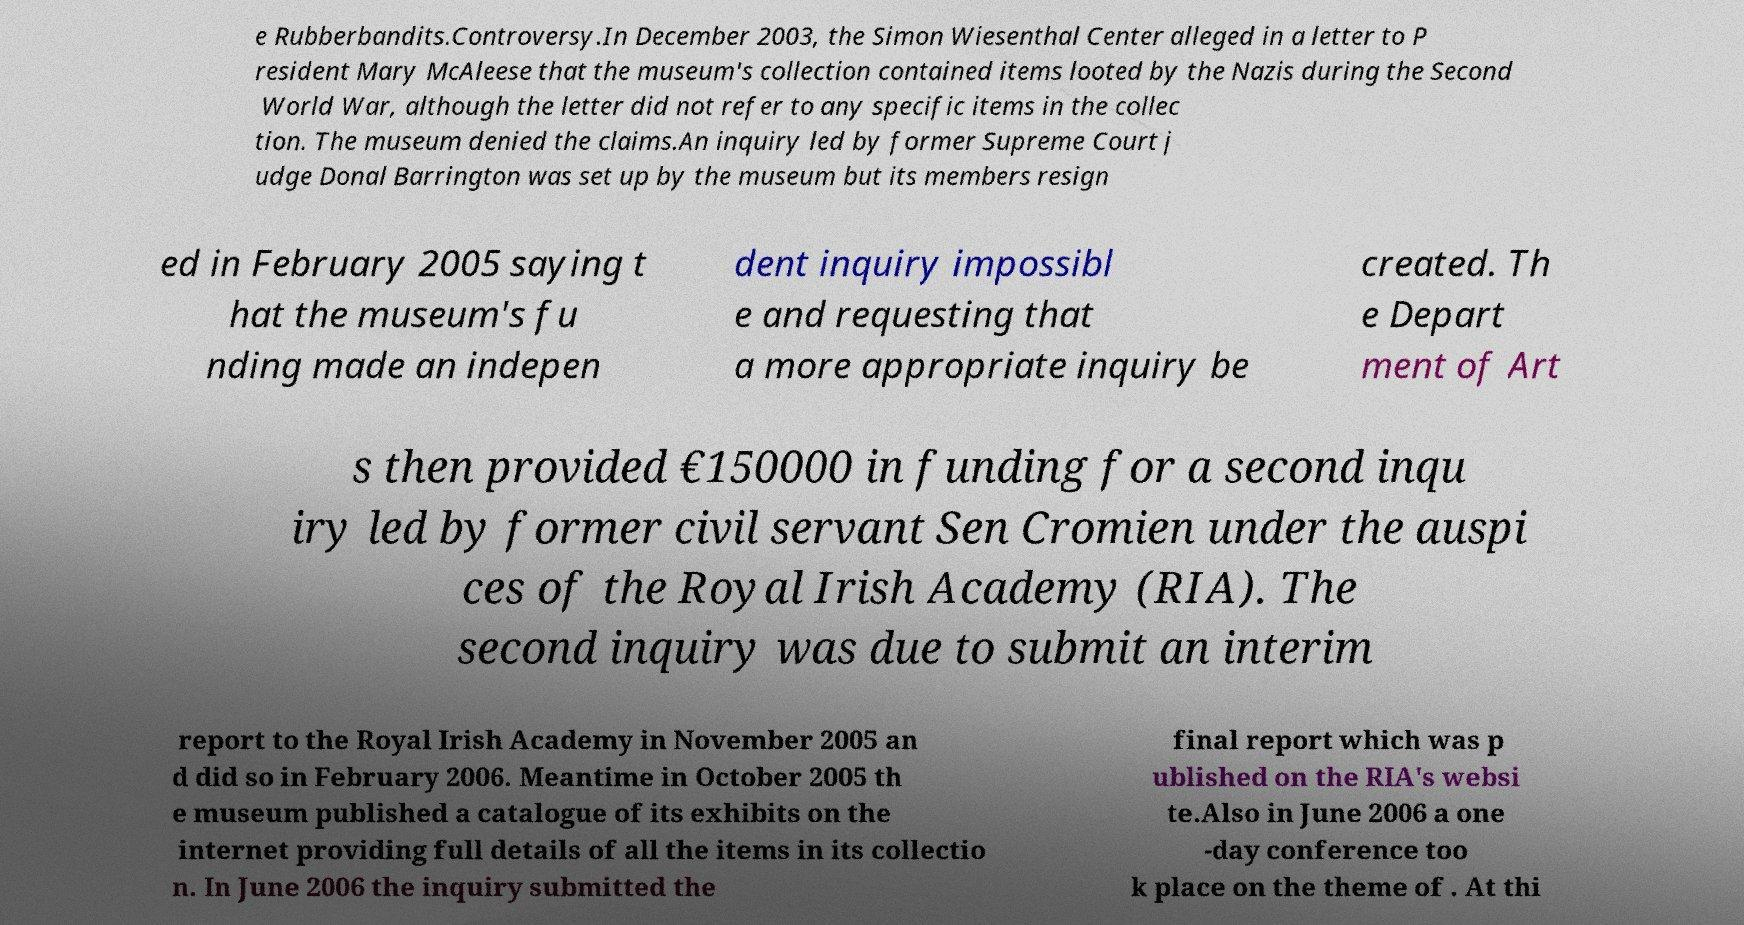Please read and relay the text visible in this image. What does it say? e Rubberbandits.Controversy.In December 2003, the Simon Wiesenthal Center alleged in a letter to P resident Mary McAleese that the museum's collection contained items looted by the Nazis during the Second World War, although the letter did not refer to any specific items in the collec tion. The museum denied the claims.An inquiry led by former Supreme Court j udge Donal Barrington was set up by the museum but its members resign ed in February 2005 saying t hat the museum's fu nding made an indepen dent inquiry impossibl e and requesting that a more appropriate inquiry be created. Th e Depart ment of Art s then provided €150000 in funding for a second inqu iry led by former civil servant Sen Cromien under the auspi ces of the Royal Irish Academy (RIA). The second inquiry was due to submit an interim report to the Royal Irish Academy in November 2005 an d did so in February 2006. Meantime in October 2005 th e museum published a catalogue of its exhibits on the internet providing full details of all the items in its collectio n. In June 2006 the inquiry submitted the final report which was p ublished on the RIA's websi te.Also in June 2006 a one -day conference too k place on the theme of . At thi 